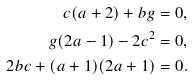<formula> <loc_0><loc_0><loc_500><loc_500>c ( a + 2 ) + b g = 0 , \\ g ( 2 a - 1 ) - 2 c ^ { 2 } = 0 , \\ 2 b c + ( a + 1 ) ( 2 a + 1 ) = 0 .</formula> 